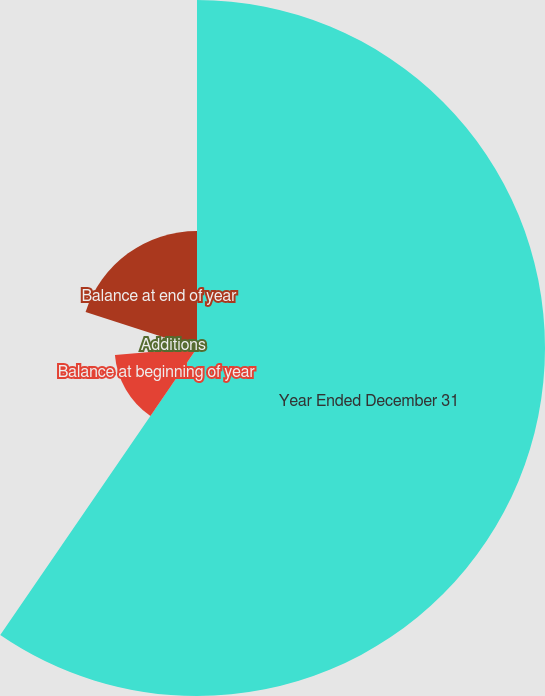Convert chart to OTSL. <chart><loc_0><loc_0><loc_500><loc_500><pie_chart><fcel>Year Ended December 31<fcel>Balance at beginning of year<fcel>Additions<fcel>Deductions<fcel>Balance at end of year<nl><fcel>59.57%<fcel>14.1%<fcel>6.12%<fcel>0.18%<fcel>20.04%<nl></chart> 